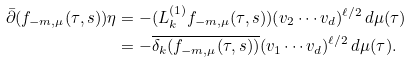<formula> <loc_0><loc_0><loc_500><loc_500>\bar { \partial } ( f _ { - m , \mu } ( \tau , s ) ) \eta & = - ( L _ { k } ^ { ( 1 ) } f _ { - m , \mu } ( \tau , s ) ) ( v _ { 2 } \cdots v _ { d } ) ^ { \ell / 2 } \, d \mu ( \tau ) \\ & = - \overline { \delta _ { k } ( f _ { - m , \mu } ( \tau , s ) ) } ( v _ { 1 } \cdots v _ { d } ) ^ { \ell / 2 } \, d \mu ( \tau ) .</formula> 